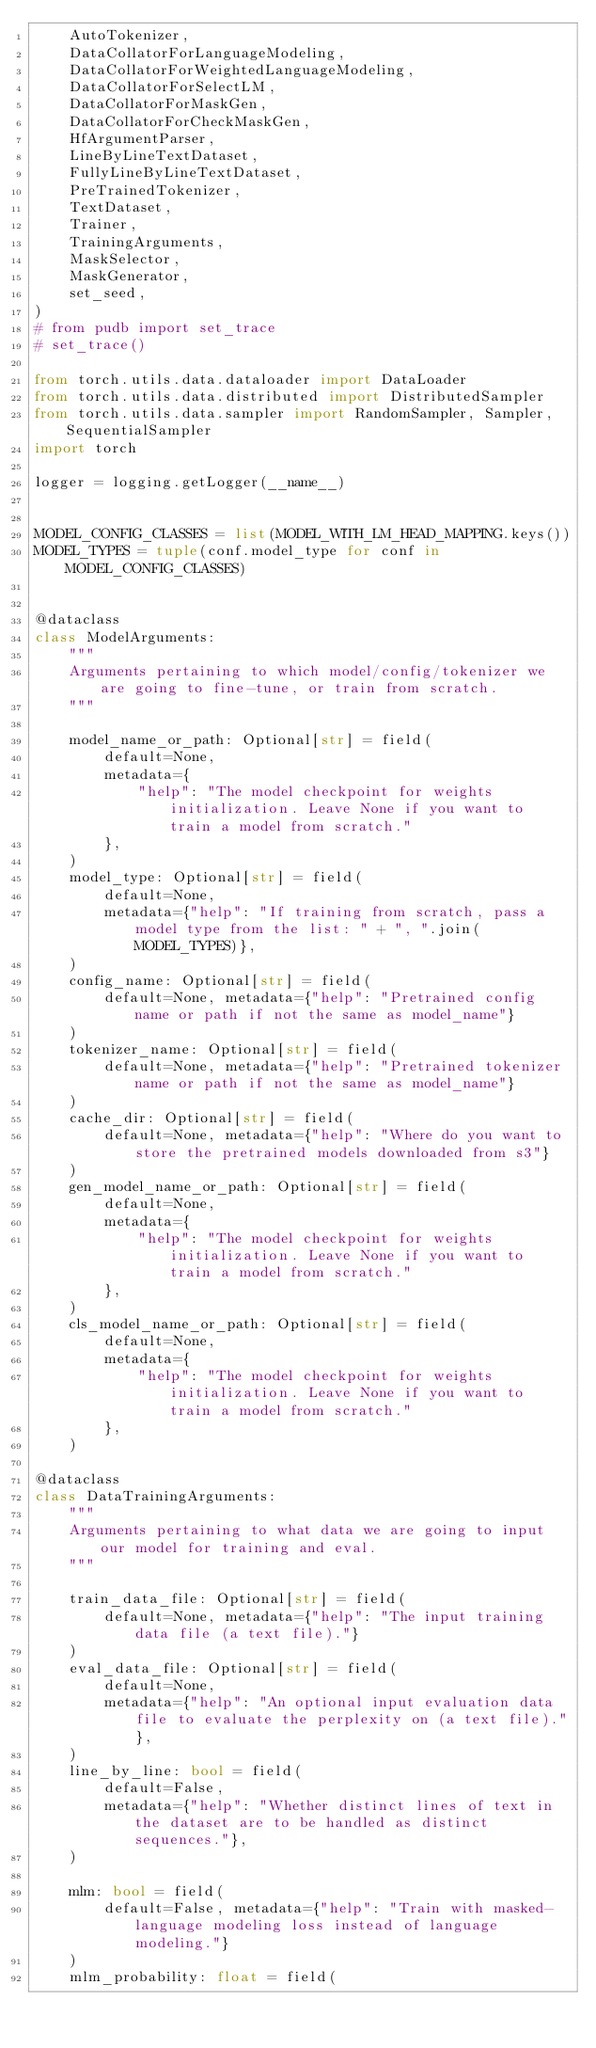<code> <loc_0><loc_0><loc_500><loc_500><_Python_>    AutoTokenizer,
    DataCollatorForLanguageModeling,
    DataCollatorForWeightedLanguageModeling,
    DataCollatorForSelectLM,
    DataCollatorForMaskGen,
    DataCollatorForCheckMaskGen,
    HfArgumentParser,
    LineByLineTextDataset,
    FullyLineByLineTextDataset,
    PreTrainedTokenizer,
    TextDataset,
    Trainer,
    TrainingArguments,
    MaskSelector,
    MaskGenerator,
    set_seed,
)
# from pudb import set_trace
# set_trace()

from torch.utils.data.dataloader import DataLoader
from torch.utils.data.distributed import DistributedSampler
from torch.utils.data.sampler import RandomSampler, Sampler, SequentialSampler
import torch

logger = logging.getLogger(__name__)


MODEL_CONFIG_CLASSES = list(MODEL_WITH_LM_HEAD_MAPPING.keys())
MODEL_TYPES = tuple(conf.model_type for conf in MODEL_CONFIG_CLASSES)


@dataclass
class ModelArguments:
    """
    Arguments pertaining to which model/config/tokenizer we are going to fine-tune, or train from scratch.
    """

    model_name_or_path: Optional[str] = field(
        default=None,
        metadata={
            "help": "The model checkpoint for weights initialization. Leave None if you want to train a model from scratch."
        },
    )
    model_type: Optional[str] = field(
        default=None,
        metadata={"help": "If training from scratch, pass a model type from the list: " + ", ".join(MODEL_TYPES)},
    )
    config_name: Optional[str] = field(
        default=None, metadata={"help": "Pretrained config name or path if not the same as model_name"}
    )
    tokenizer_name: Optional[str] = field(
        default=None, metadata={"help": "Pretrained tokenizer name or path if not the same as model_name"}
    )
    cache_dir: Optional[str] = field(
        default=None, metadata={"help": "Where do you want to store the pretrained models downloaded from s3"}
    )
    gen_model_name_or_path: Optional[str] = field(
        default=None,
        metadata={
            "help": "The model checkpoint for weights initialization. Leave None if you want to train a model from scratch."
        },
    )
    cls_model_name_or_path: Optional[str] = field(
        default=None,
        metadata={
            "help": "The model checkpoint for weights initialization. Leave None if you want to train a model from scratch."
        },
    )
    
@dataclass
class DataTrainingArguments:
    """
    Arguments pertaining to what data we are going to input our model for training and eval.
    """

    train_data_file: Optional[str] = field(
        default=None, metadata={"help": "The input training data file (a text file)."}
    )
    eval_data_file: Optional[str] = field(
        default=None,
        metadata={"help": "An optional input evaluation data file to evaluate the perplexity on (a text file)."},
    )
    line_by_line: bool = field(
        default=False,
        metadata={"help": "Whether distinct lines of text in the dataset are to be handled as distinct sequences."},
    )

    mlm: bool = field(
        default=False, metadata={"help": "Train with masked-language modeling loss instead of language modeling."}
    )
    mlm_probability: float = field(</code> 